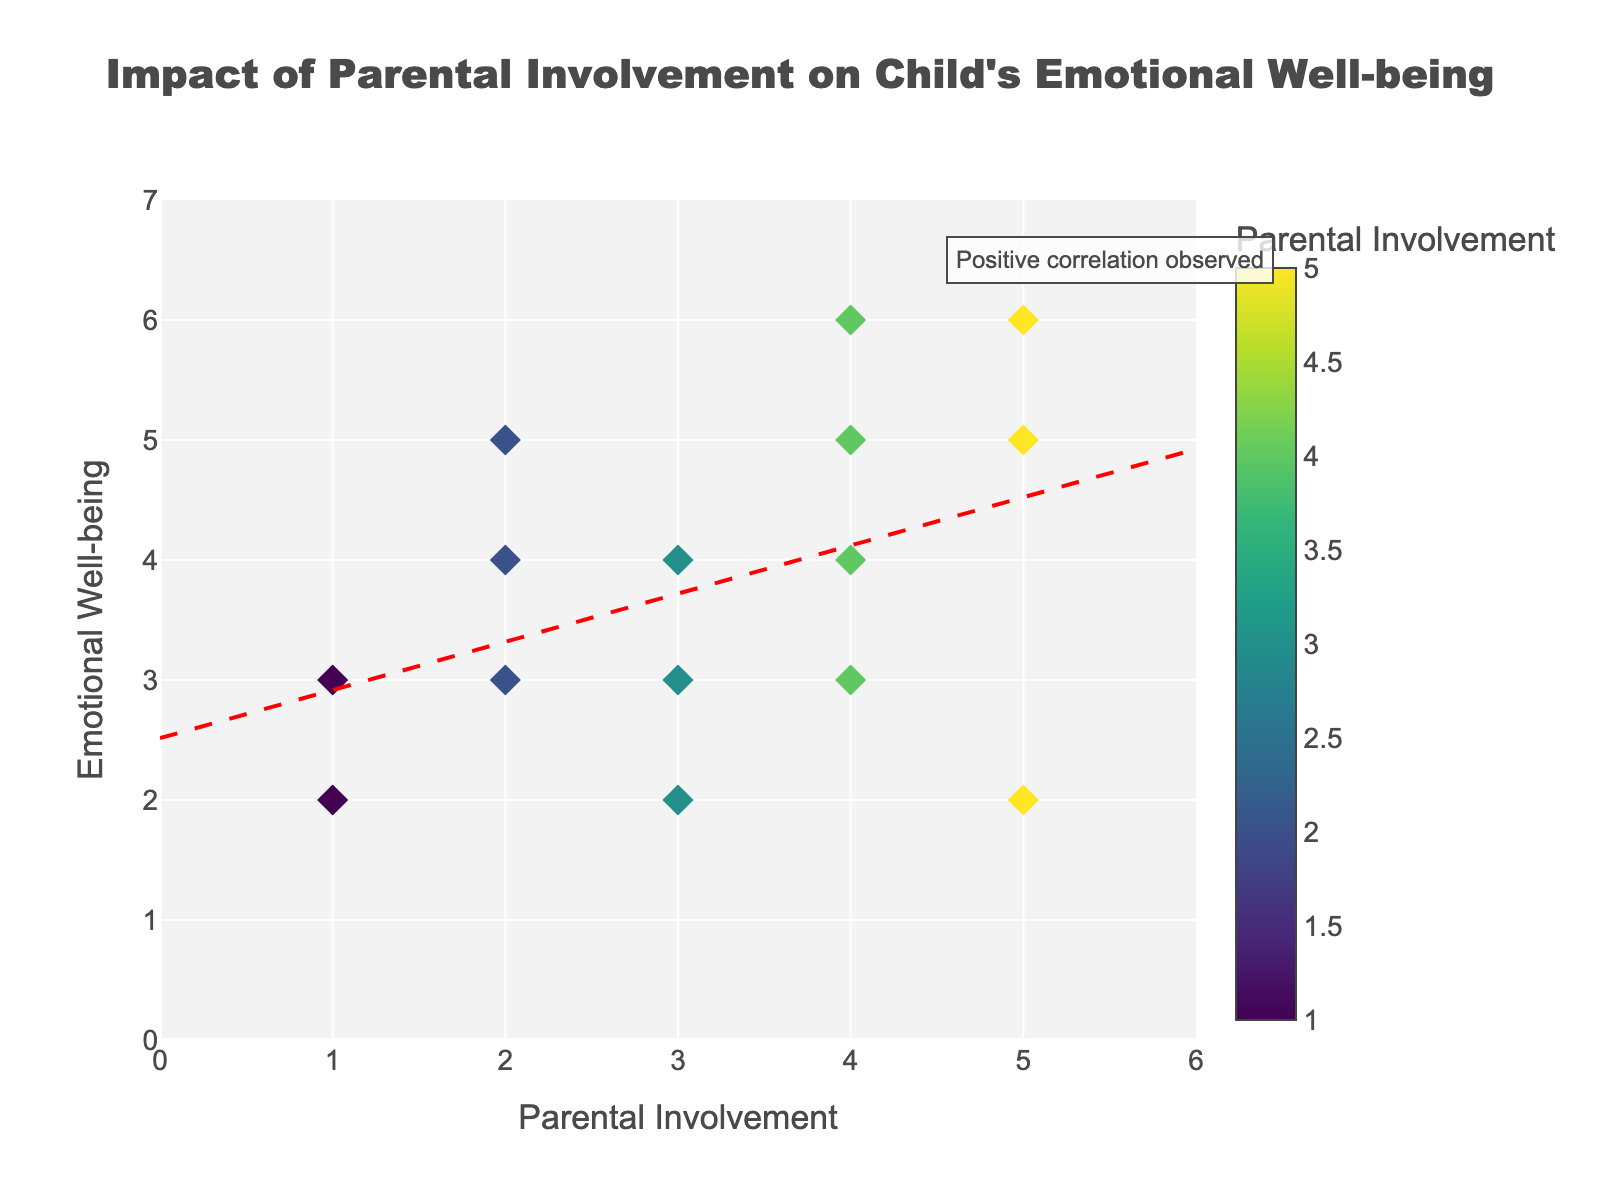How many data points are plotted in the scatter plot? Count each marker in the scatter plot. There are 15 markers plotted.
Answer: 15 What is the title of the scatter plot? Look at the title at the top of the scatter plot. It reads "Impact of Parental Involvement on Child's Emotional Well-being".
Answer: Impact of Parental Involvement on Child's Emotional Well-being Which axis represents Parental Involvement? Look at the label on the horizontal (X) axis. The X-axis is labeled "Parental Involvement".
Answer: X-axis What color is used to show the highest level of Parental Involvement? Look at the color scale next to the plot. The highest level of Parental Involvement corresponds to 5, and it is represented by a dark color in the Viridis scale.
Answer: Dark color Which axis shows the emotional well-being of children? Look at the label on the vertical (Y) axis. The Y-axis is labeled "Emotional Well-being".
Answer: Y-axis What does the red dashed line in the scatter plot represent? The red dashed line is a trend line that shows the general trend or correlation between Parental Involvement and Emotional Well-being. This is often derived from a best-fit line.
Answer: Trend line What's the emotional well-being value when Parental Involvement is at its minimum? Look for the lowest value on the X-axis (Parental Involvement), which is 1. The corresponding Y-axis values (Emotional Well-being) are given for different points - they are 2 and 3 for this X value.
Answer: 2 and 3 What is the average emotional well-being score for a Parental Involvement score of 4? Identify the points where Parental Involvement is 4, then average their Y-values (Emotional Well-being): 5, 4, 3, and 6. The average is (5+4+3+6)/4 = 18/4 = 4.5
Answer: 4.5 Which child has the highest emotional well-being? Find the highest point on the Y-axis and check its hover label. The highest emotional well-being score is 6, observed for multiple Parental Involvement levels, but unique to Child 4.
Answer: Child 4 Is there a positive correlation between Parental Involvement and Emotional Well-being? Observe the trend line and the general direction of the points. The trend line is upward-sloping from left to right, indicating a positive correlation.
Answer: Yes 